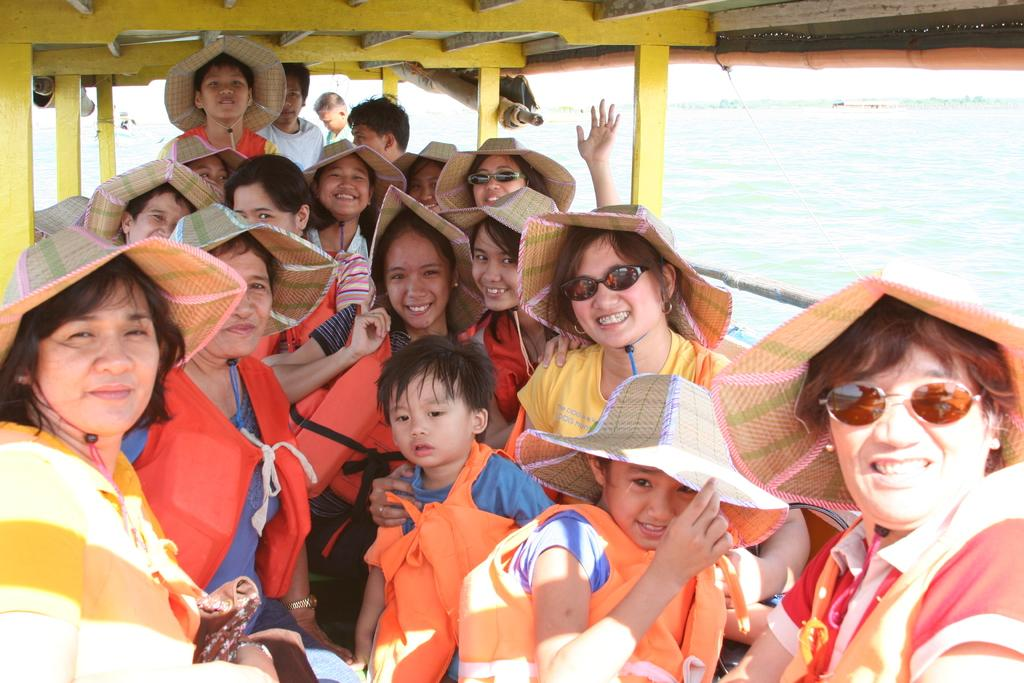What is the main subject of the image? The main subject of the image is a group of people. Where are the people located in the image? The people are in a boat in the image. What accessories can be seen on some of the people in the image? Some people in the group are wearing spectacles and caps. What can be seen in the background of the image? There is water visible in the background of the image. What is the tendency of the tiger in the image? There is no tiger present in the image. Can the people in the boat use the can to catch fish in the image? The image does not show any fishing equipment, such as a can, so it cannot be determined if the people can catch fish. 